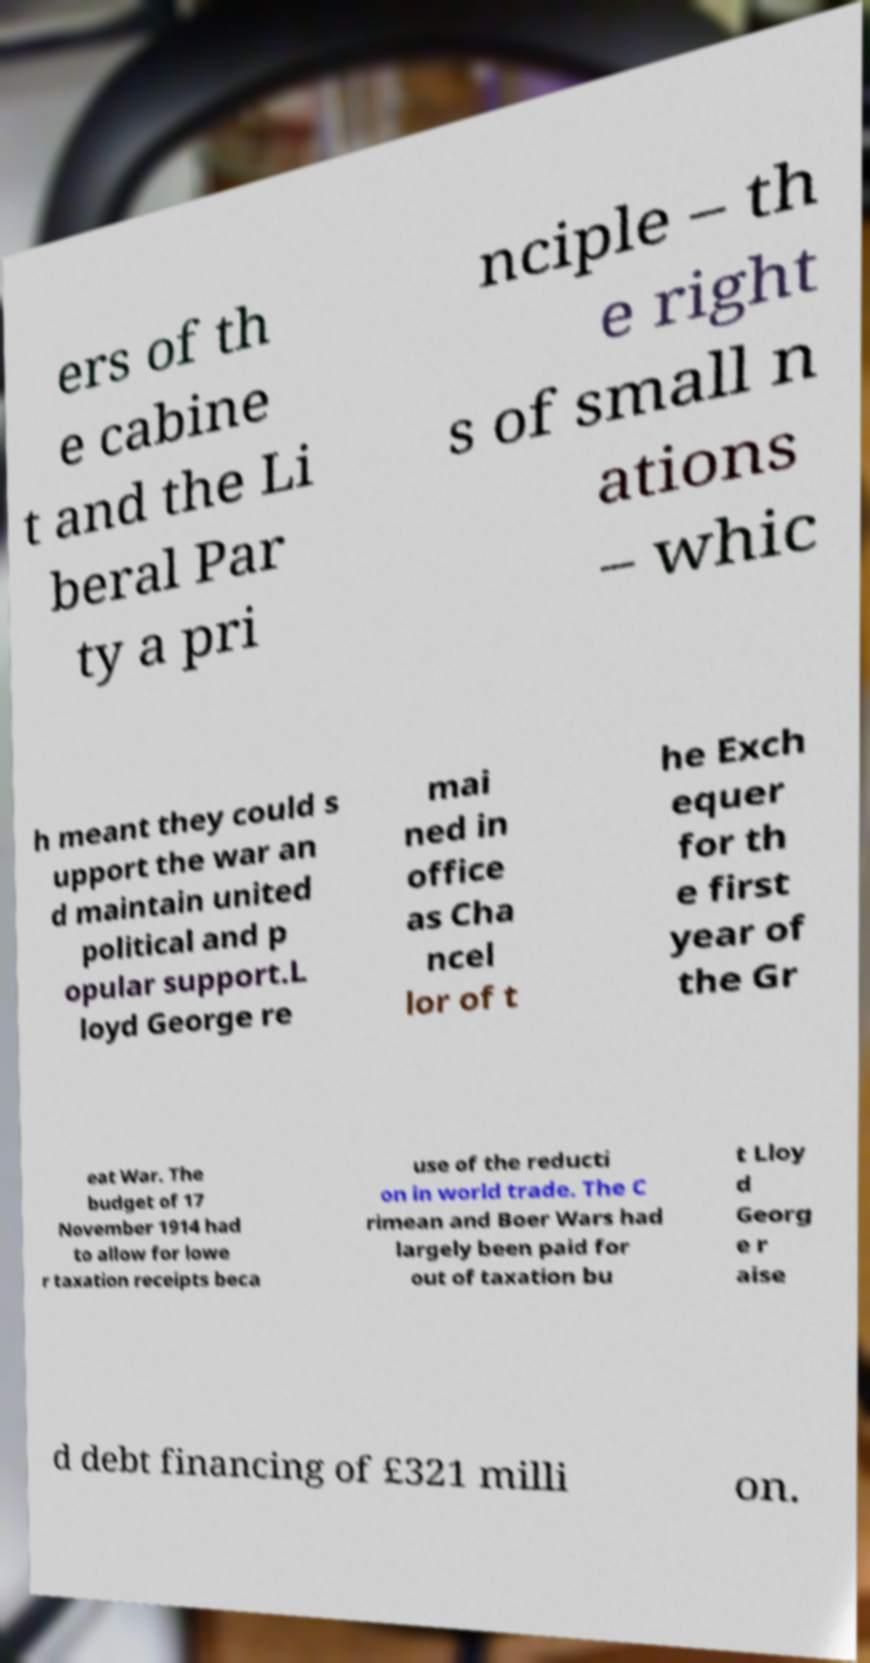Please identify and transcribe the text found in this image. ers of th e cabine t and the Li beral Par ty a pri nciple – th e right s of small n ations – whic h meant they could s upport the war an d maintain united political and p opular support.L loyd George re mai ned in office as Cha ncel lor of t he Exch equer for th e first year of the Gr eat War. The budget of 17 November 1914 had to allow for lowe r taxation receipts beca use of the reducti on in world trade. The C rimean and Boer Wars had largely been paid for out of taxation bu t Lloy d Georg e r aise d debt financing of £321 milli on. 